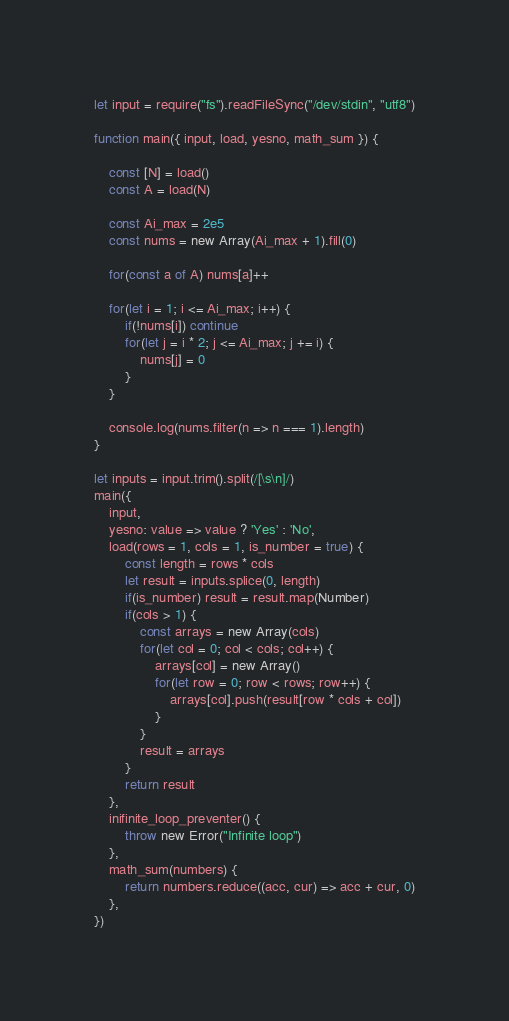<code> <loc_0><loc_0><loc_500><loc_500><_JavaScript_>
let input = require("fs").readFileSync("/dev/stdin", "utf8")

function main({ input, load, yesno, math_sum }) {

    const [N] = load()
    const A = load(N)

    const Ai_max = 2e5
    const nums = new Array(Ai_max + 1).fill(0)

    for(const a of A) nums[a]++

    for(let i = 1; i <= Ai_max; i++) {
        if(!nums[i]) continue
        for(let j = i * 2; j <= Ai_max; j += i) {
            nums[j] = 0
        }
    }

    console.log(nums.filter(n => n === 1).length)
}

let inputs = input.trim().split(/[\s\n]/)
main({
    input,
    yesno: value => value ? 'Yes' : 'No',
    load(rows = 1, cols = 1, is_number = true) {
        const length = rows * cols
        let result = inputs.splice(0, length)
        if(is_number) result = result.map(Number)
        if(cols > 1) {
            const arrays = new Array(cols)
            for(let col = 0; col < cols; col++) {
                arrays[col] = new Array()
                for(let row = 0; row < rows; row++) {
                    arrays[col].push(result[row * cols + col])
                }
            }
            result = arrays
        }
        return result
    },
    inifinite_loop_preventer() {
        throw new Error("Infinite loop")
    },
    math_sum(numbers) {
        return numbers.reduce((acc, cur) => acc + cur, 0)
    },
})
</code> 